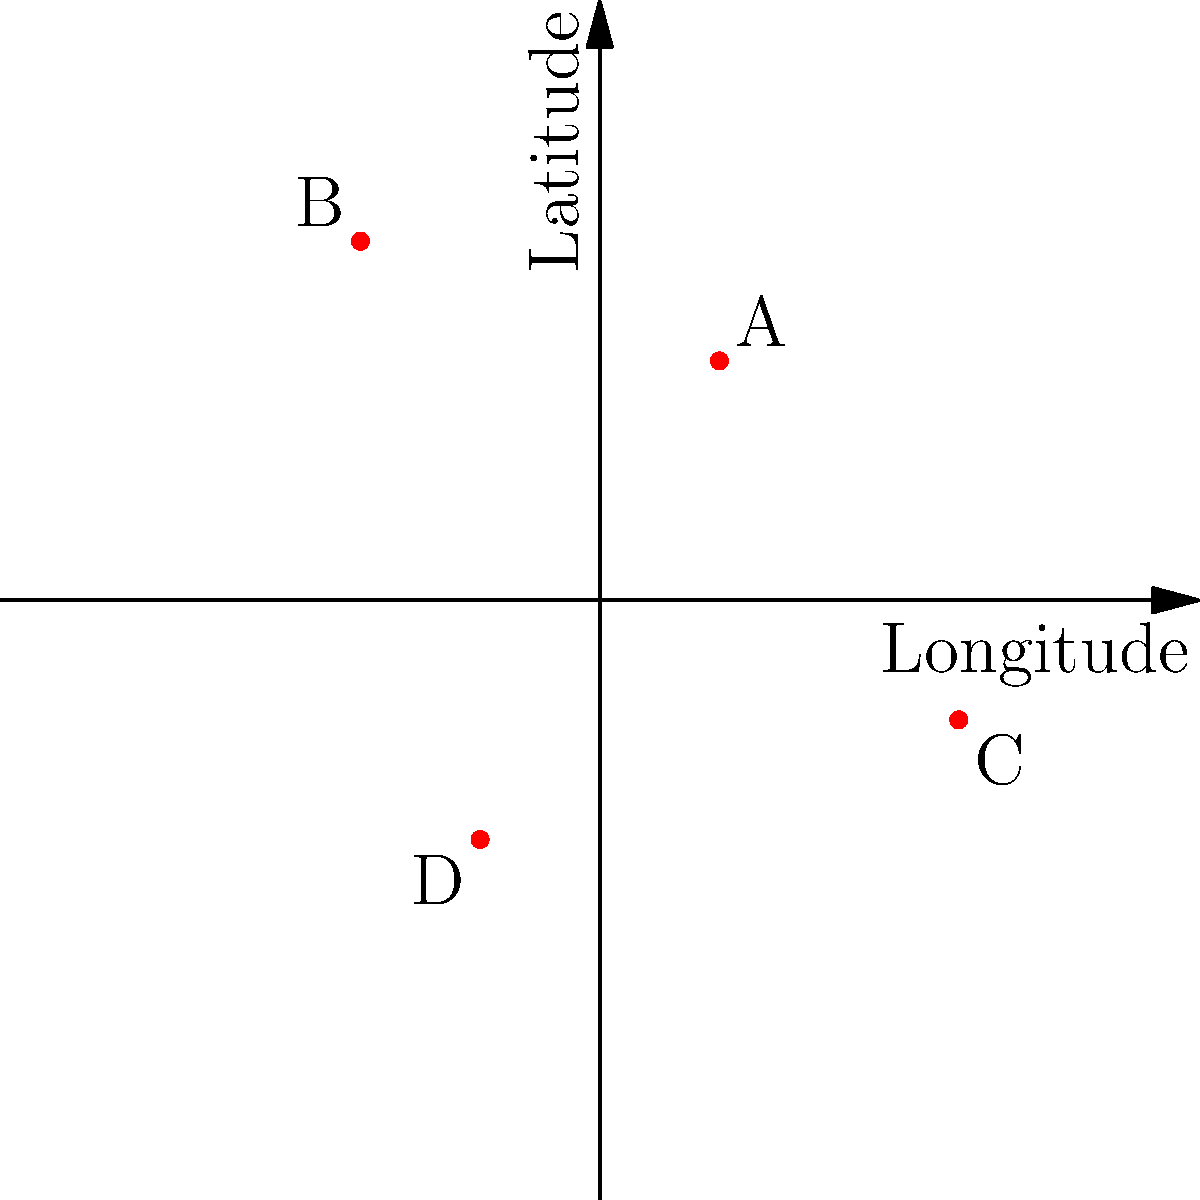As a small business owner archiving customer data, you've plotted four customer locations (A, B, C, and D) on a 2D map using latitude and longitude coordinates. Which customer is located in the southwestern quadrant of the map? To determine which customer is in the southwestern quadrant, we need to follow these steps:

1. Understand the coordinate system:
   - The x-axis represents longitude (east-west)
   - The y-axis represents latitude (north-south)
   - The origin (0,0) is at the center of the map

2. Identify the quadrants:
   - Northeast (NE): positive x, positive y
   - Northwest (NW): negative x, positive y
   - Southeast (SE): positive x, negative y
   - Southwest (SW): negative x, negative y

3. Analyze each customer's location:
   - Customer A: (1,2) - in the northeast quadrant
   - Customer B: (-2,3) - in the northwest quadrant
   - Customer C: (3,-1) - in the southeast quadrant
   - Customer D: (-1,-2) - in the southwest quadrant

4. Identify the customer in the southwestern quadrant:
   Customer D is the only one with both negative x (longitude) and negative y (latitude) coordinates, placing it in the southwestern quadrant.
Answer: D 